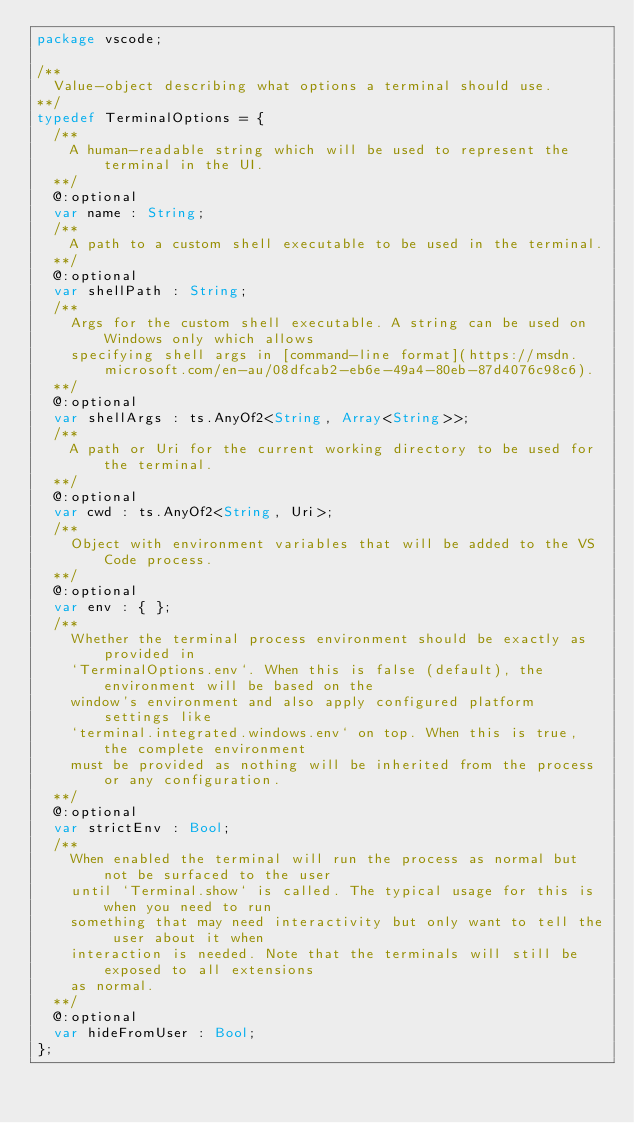Convert code to text. <code><loc_0><loc_0><loc_500><loc_500><_Haxe_>package vscode;

/**
	Value-object describing what options a terminal should use.
**/
typedef TerminalOptions = {
	/**
		A human-readable string which will be used to represent the terminal in the UI.
	**/
	@:optional
	var name : String;
	/**
		A path to a custom shell executable to be used in the terminal.
	**/
	@:optional
	var shellPath : String;
	/**
		Args for the custom shell executable. A string can be used on Windows only which allows
		specifying shell args in [command-line format](https://msdn.microsoft.com/en-au/08dfcab2-eb6e-49a4-80eb-87d4076c98c6).
	**/
	@:optional
	var shellArgs : ts.AnyOf2<String, Array<String>>;
	/**
		A path or Uri for the current working directory to be used for the terminal.
	**/
	@:optional
	var cwd : ts.AnyOf2<String, Uri>;
	/**
		Object with environment variables that will be added to the VS Code process.
	**/
	@:optional
	var env : { };
	/**
		Whether the terminal process environment should be exactly as provided in
		`TerminalOptions.env`. When this is false (default), the environment will be based on the
		window's environment and also apply configured platform settings like
		`terminal.integrated.windows.env` on top. When this is true, the complete environment
		must be provided as nothing will be inherited from the process or any configuration.
	**/
	@:optional
	var strictEnv : Bool;
	/**
		When enabled the terminal will run the process as normal but not be surfaced to the user
		until `Terminal.show` is called. The typical usage for this is when you need to run
		something that may need interactivity but only want to tell the user about it when
		interaction is needed. Note that the terminals will still be exposed to all extensions
		as normal.
	**/
	@:optional
	var hideFromUser : Bool;
};</code> 